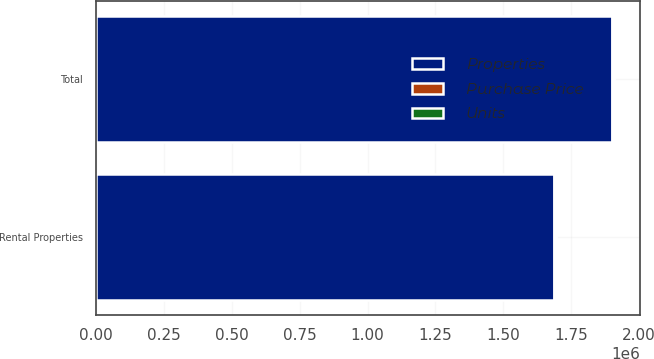Convert chart to OTSL. <chart><loc_0><loc_0><loc_500><loc_500><stacked_bar_chart><ecel><fcel>Rental Properties<fcel>Total<nl><fcel>Units<fcel>36<fcel>36<nl><fcel>Purchase Price<fcel>8167<fcel>8167<nl><fcel>Properties<fcel>1.68644e+06<fcel>1.89928e+06<nl></chart> 